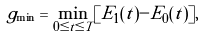<formula> <loc_0><loc_0><loc_500><loc_500>g _ { \min } = \min _ { 0 \leq t \leq T } [ E _ { 1 } ( t ) - E _ { 0 } ( t ) ] ,</formula> 